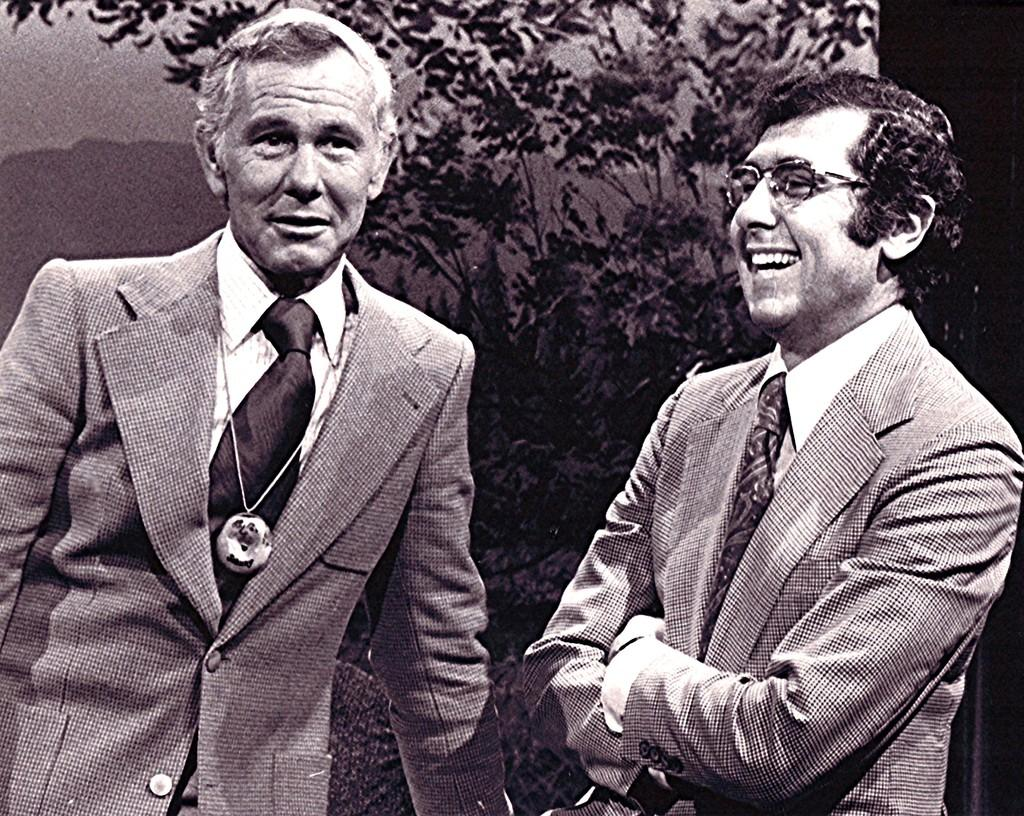What is the color scheme of the image? The image is black and white. How many people are in the image? There are two persons in the image. Can you describe the appearance of one of the persons? The person on the right side is wearing glasses (specs). What can be seen in the background of the image? There are trees in the background of the image. How many worms are crawling on the person wearing glasses in the image? There are no worms present in the image, and therefore no such activity can be observed. 